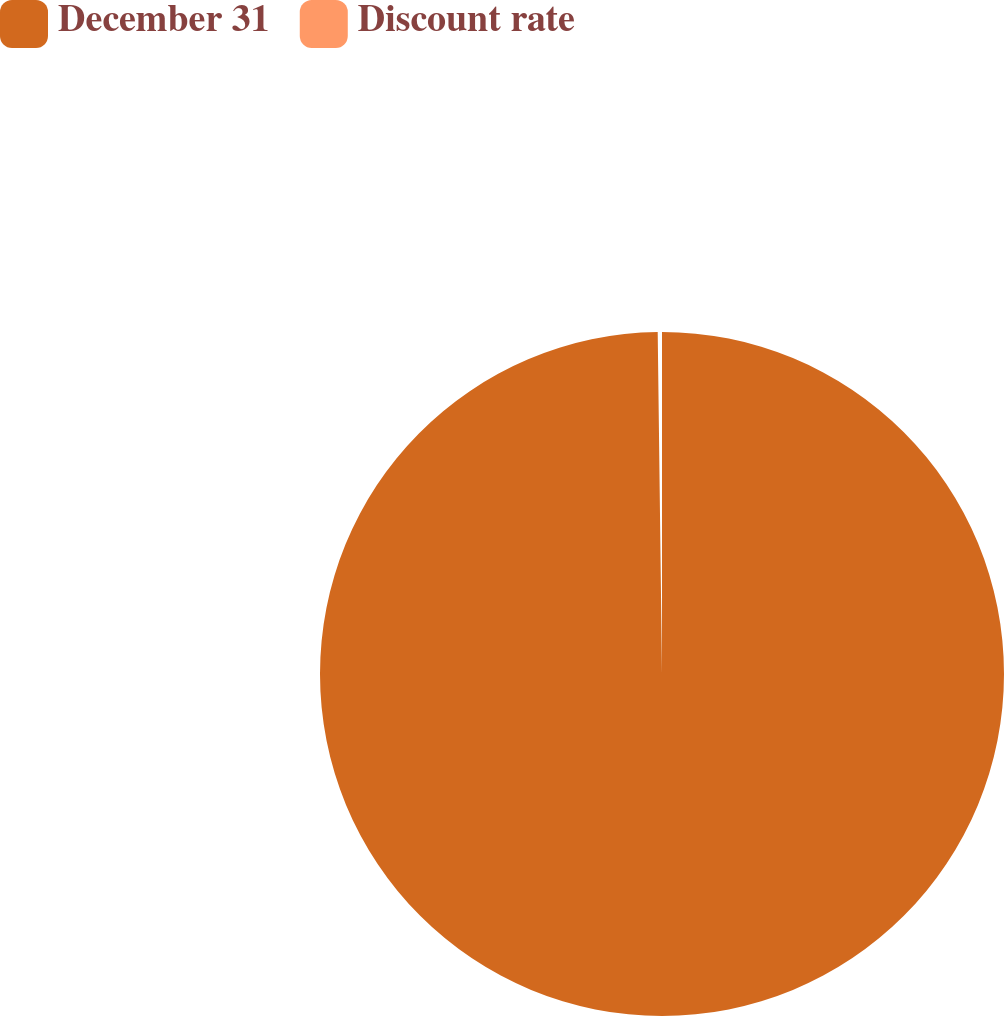Convert chart to OTSL. <chart><loc_0><loc_0><loc_500><loc_500><pie_chart><fcel>December 31<fcel>Discount rate<nl><fcel>99.8%<fcel>0.2%<nl></chart> 